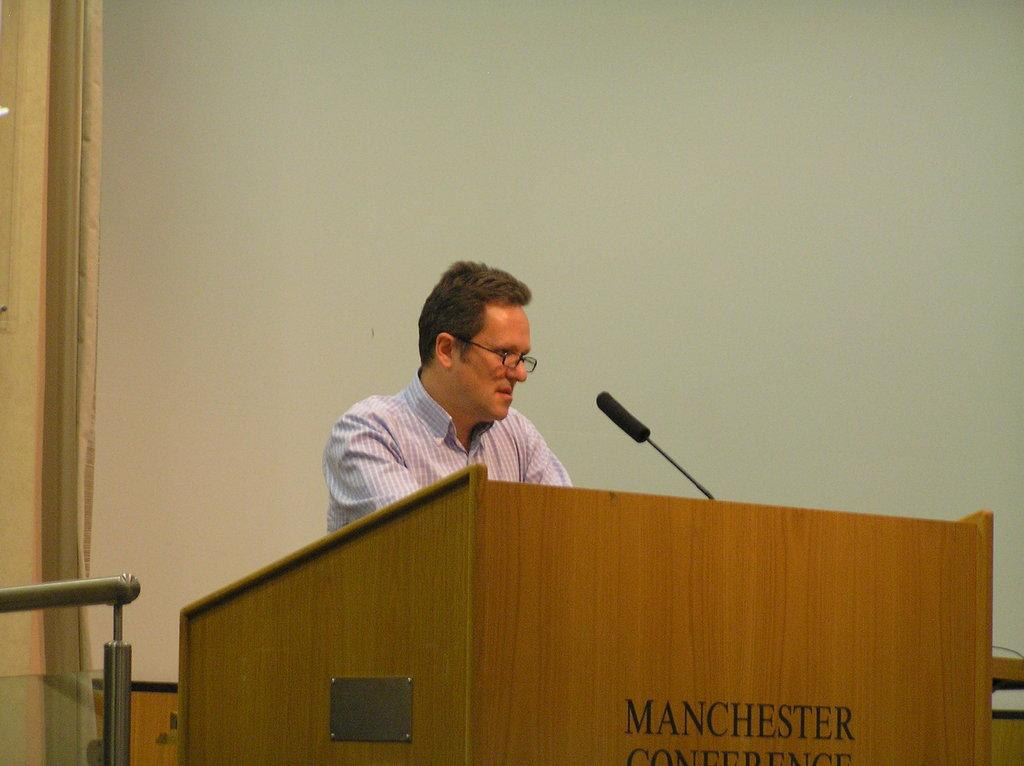Who or what is in the image? There is a person in the image. What is the person standing behind? The person is behind a brown-colored podium. What is on the podium? There is a microphone on the podium. What colors can be seen in the background of the image? The background of the image is white and cream-colored. How many hydrants are visible in the image? There are no hydrants present in the image. What scientific experiment is being conducted in the image? There is no scientific experiment depicted in the image. 